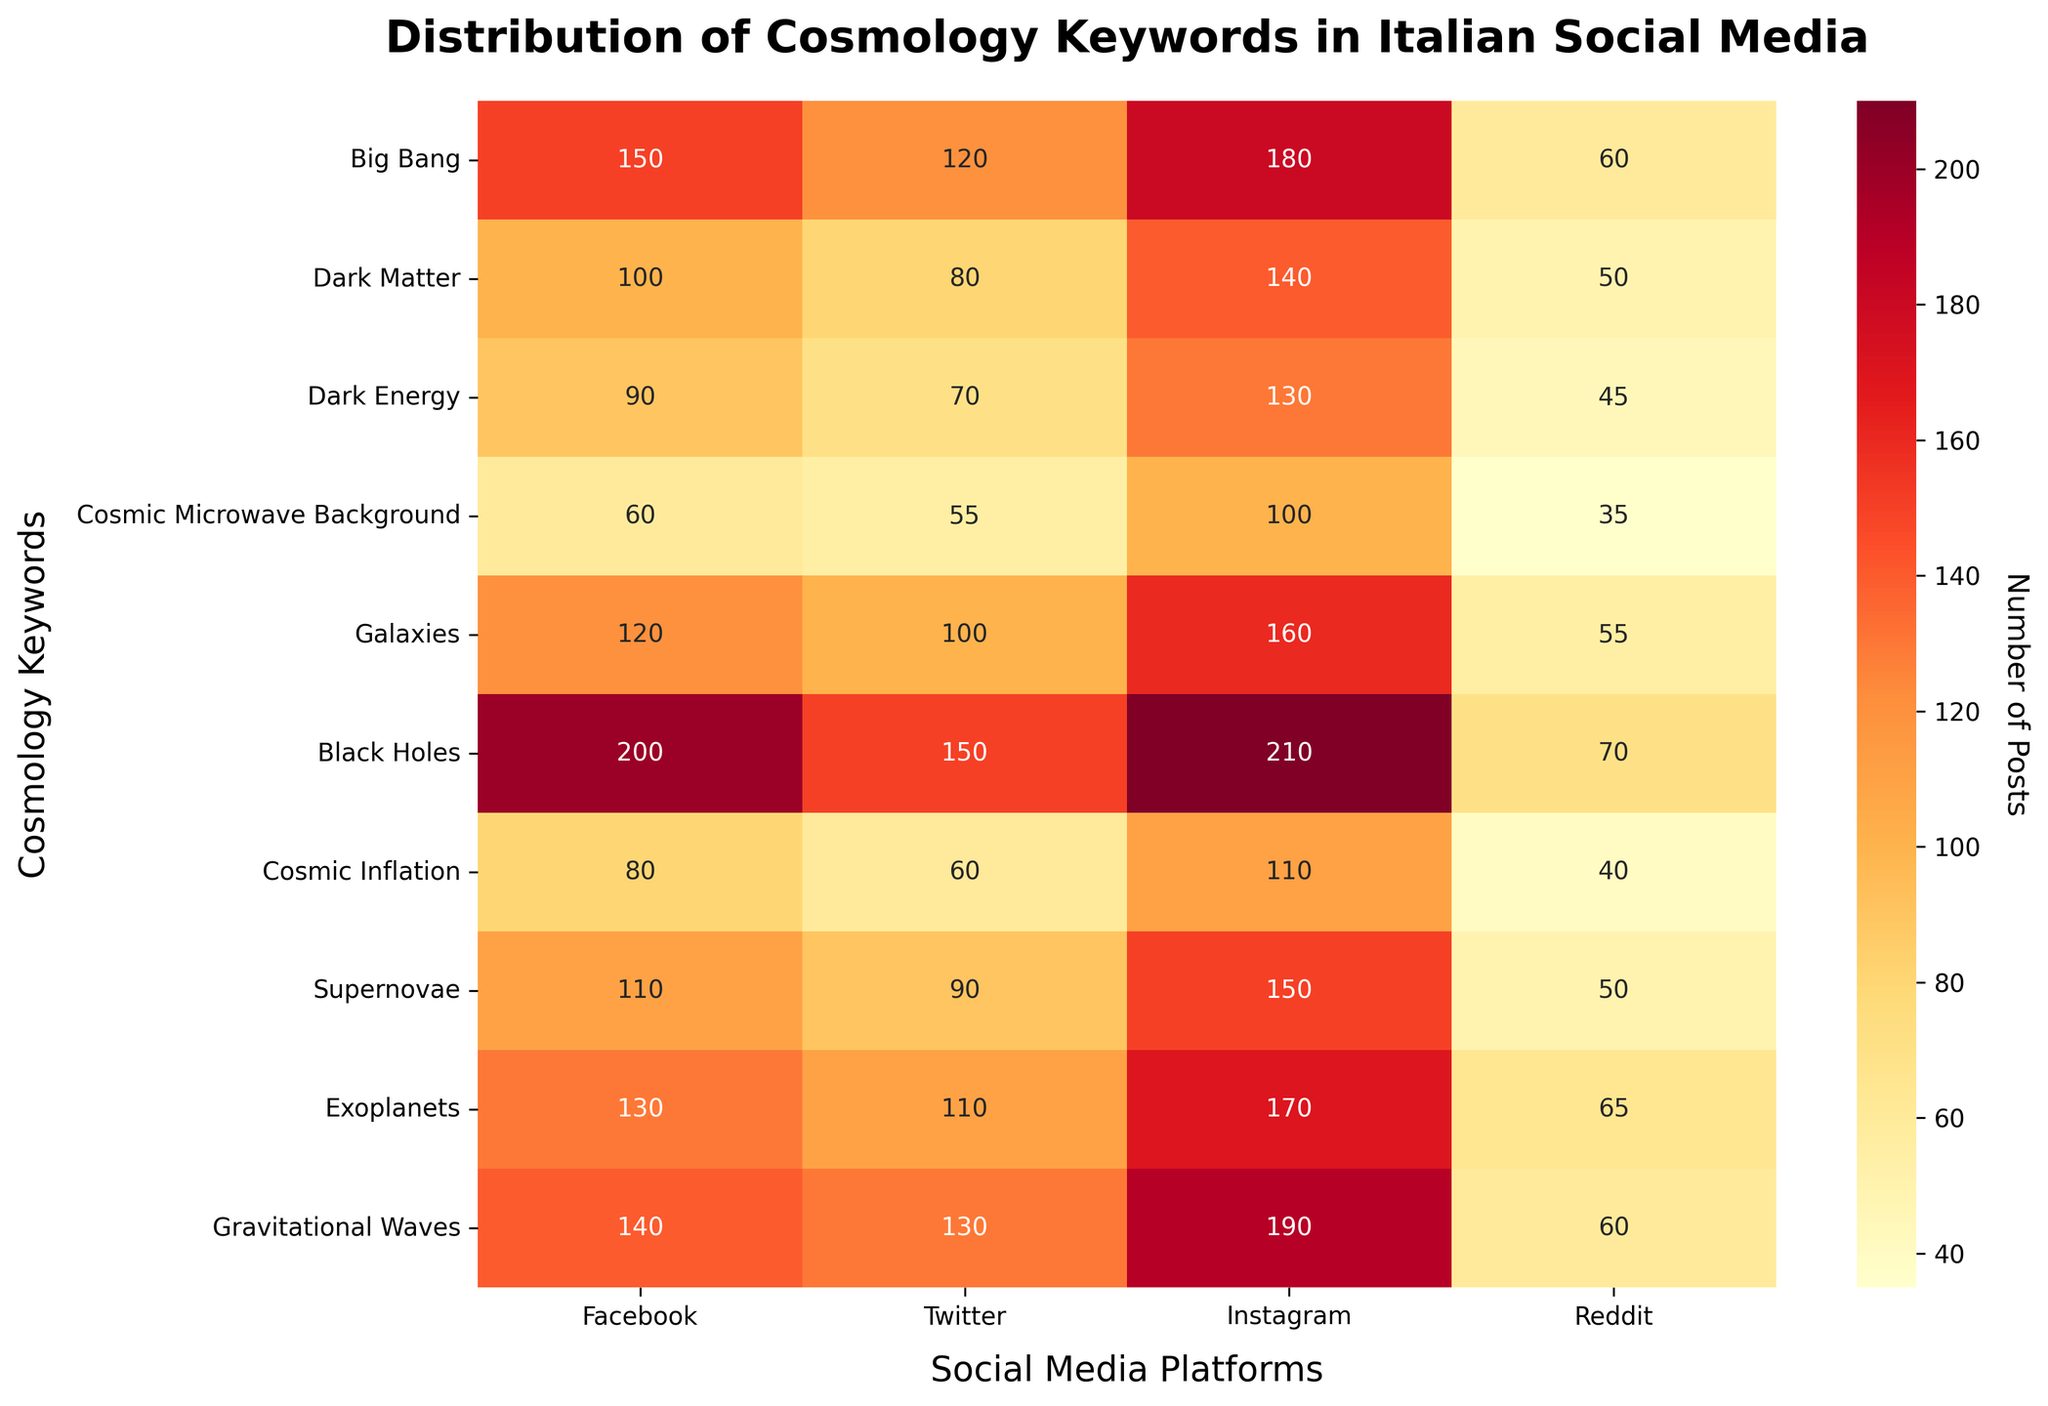What's the title of the plot? The title of the plot is displayed at the top of the figure and generally explains the purpose or focus of the visualization.
Answer: Distribution of Cosmology Keywords in Italian Social Media Which social media platform has the highest number of posts for 'Black Holes'? Look at the row for 'Black Holes' in the heatmap and find the column with the highest number.
Answer: Instagram How many posts mention 'Dark Matter' on Facebook and Instagram combined? Find the values for 'Dark Matter' on Facebook and Instagram, then add them together. 100 (Facebook) + 140 (Instagram) = 240
Answer: 240 What is the most mentioned keyword on Twitter? Look at all the values in the Twitter column and find the highest number. The corresponding row indicates the keyword.
Answer: Black Holes Which keyword has the least mentions on Reddit? Review the values in the Reddit column and find the smallest number. The corresponding row indicates the keyword.
Answer: Cosmic Microwave Background How many total posts mention 'Galaxies' across all the platforms? Add the values for 'Galaxies' across Facebook, Twitter, Instagram, and Reddit. 120 (Facebook) + 100 (Twitter) + 160 (Instagram) + 55 (Reddit) = 435
Answer: 435 Compare the number of mentions of 'Exoplanets' and 'Gravitational Waves' on Instagram. Which one is higher? Look at the values for 'Exoplanets' and 'Gravitational Waves' in the Instagram column. Compare the two numbers.
Answer: Gravitational Waves Which keyword has more mentions on Facebook compared to Reddit? Identify the keywords where the Facebook column value is greater than the Reddit column value.
Answer: All keywords except 'Black Holes' Is the number of mentions for 'Dark Energy' on Twitter greater than the number of mentions for 'Cosmic Inflation' on Reddit? Look at the values for 'Dark Energy' on Twitter and 'Cosmic Inflation' on Reddit. Compare the two numbers.
Answer: Yes What is the average number of posts for 'Supernovae' across all platforms? Add the number of posts for 'Supernovae' across all platforms and divide by the number of platforms. (110 + 90 + 150 + 50) / 4 = 100
Answer: 100 